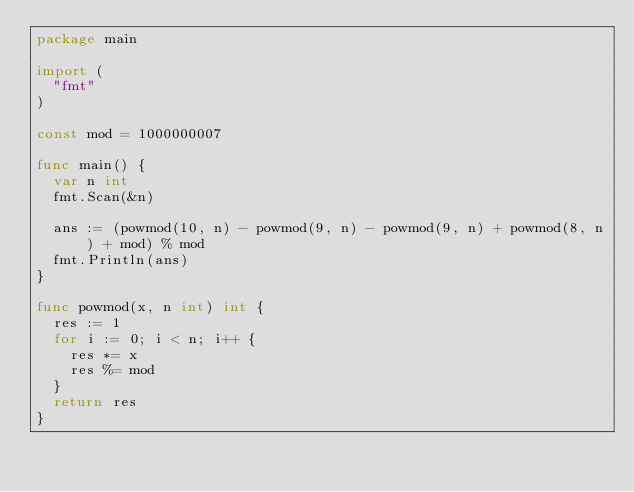<code> <loc_0><loc_0><loc_500><loc_500><_Go_>package main

import (
	"fmt"
)

const mod = 1000000007

func main() {
	var n int
	fmt.Scan(&n)

	ans := (powmod(10, n) - powmod(9, n) - powmod(9, n) + powmod(8, n) + mod) % mod
	fmt.Println(ans)
}

func powmod(x, n int) int {
	res := 1
	for i := 0; i < n; i++ {
		res *= x
		res %= mod
	}
	return res
}
</code> 